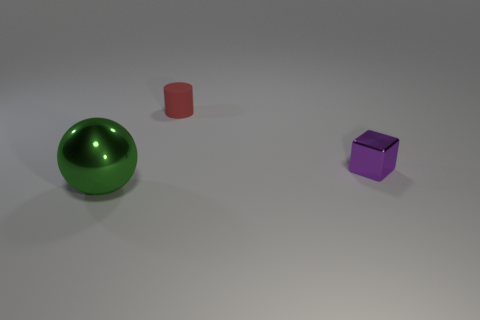Add 2 spheres. How many objects exist? 5 Subtract all red balls. Subtract all brown cubes. How many balls are left? 1 Subtract all brown cubes. How many red balls are left? 0 Subtract all red shiny objects. Subtract all matte cylinders. How many objects are left? 2 Add 3 matte cylinders. How many matte cylinders are left? 4 Add 3 large gray metal cylinders. How many large gray metal cylinders exist? 3 Subtract 0 blue cubes. How many objects are left? 3 Subtract all cylinders. How many objects are left? 2 Subtract 1 cylinders. How many cylinders are left? 0 